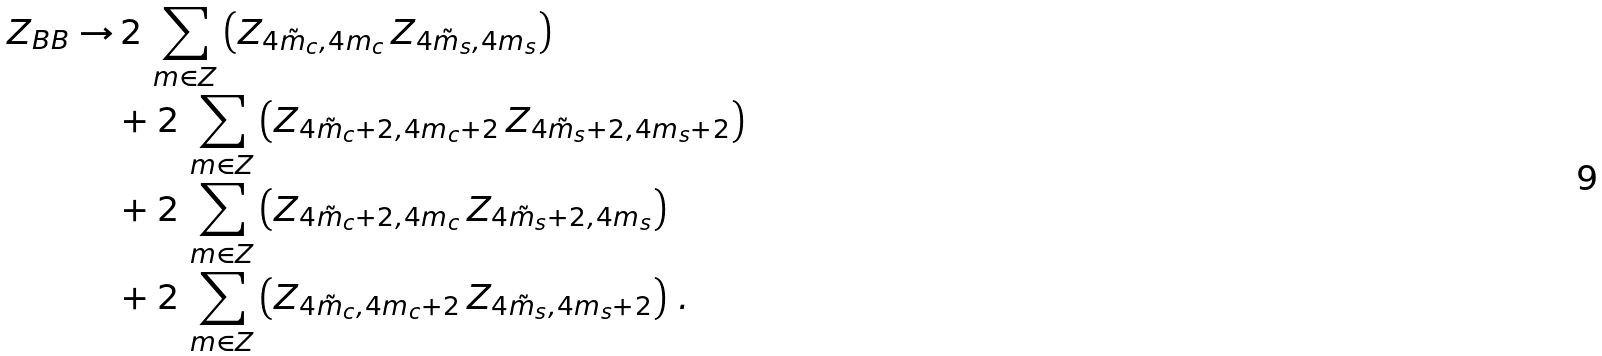<formula> <loc_0><loc_0><loc_500><loc_500>Z _ { B B } \to & \, 2 \, \sum _ { m \in Z } \left ( Z _ { 4 \tilde { m } _ { c } , 4 m _ { c } } \, Z _ { 4 \tilde { m } _ { s } , 4 m _ { s } } \right ) \\ & + 2 \, \sum _ { m \in Z } \left ( Z _ { 4 \tilde { m } _ { c } + 2 , 4 m _ { c } + 2 } \, Z _ { 4 \tilde { m } _ { s } + 2 , 4 m _ { s } + 2 } \right ) \\ & + 2 \, \sum _ { m \in Z } \left ( Z _ { 4 \tilde { m } _ { c } + 2 , 4 m _ { c } } \, Z _ { 4 \tilde { m } _ { s } + 2 , 4 m _ { s } } \right ) \\ & + 2 \, \sum _ { m \in Z } \left ( Z _ { 4 \tilde { m } _ { c } , 4 m _ { c } + 2 } \, Z _ { 4 \tilde { m } _ { s } , 4 m _ { s } + 2 } \right ) \, .</formula> 